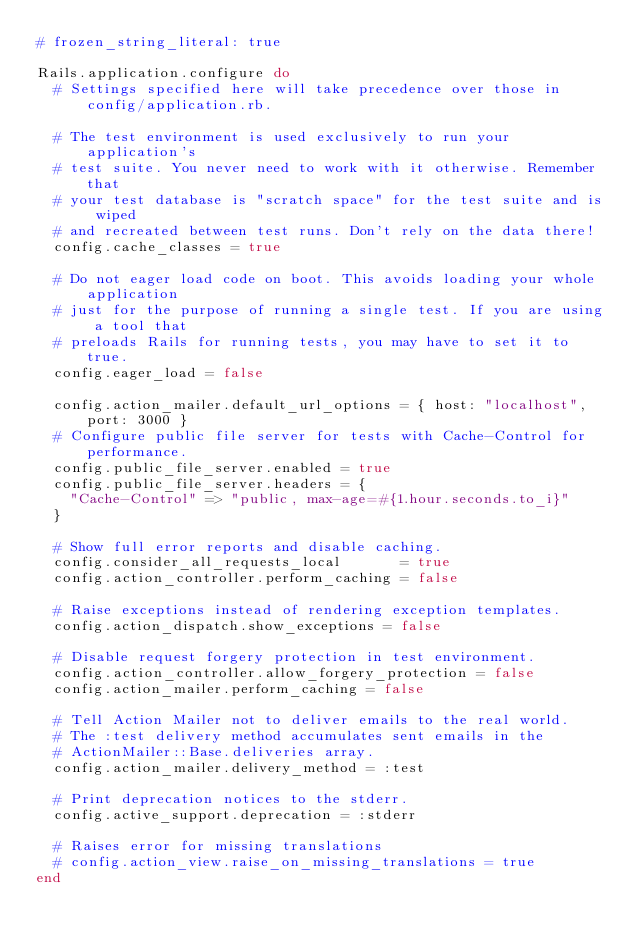<code> <loc_0><loc_0><loc_500><loc_500><_Ruby_># frozen_string_literal: true

Rails.application.configure do
  # Settings specified here will take precedence over those in config/application.rb.

  # The test environment is used exclusively to run your application's
  # test suite. You never need to work with it otherwise. Remember that
  # your test database is "scratch space" for the test suite and is wiped
  # and recreated between test runs. Don't rely on the data there!
  config.cache_classes = true

  # Do not eager load code on boot. This avoids loading your whole application
  # just for the purpose of running a single test. If you are using a tool that
  # preloads Rails for running tests, you may have to set it to true.
  config.eager_load = false

  config.action_mailer.default_url_options = { host: "localhost", port: 3000 }
  # Configure public file server for tests with Cache-Control for performance.
  config.public_file_server.enabled = true
  config.public_file_server.headers = {
    "Cache-Control" => "public, max-age=#{1.hour.seconds.to_i}"
  }

  # Show full error reports and disable caching.
  config.consider_all_requests_local       = true
  config.action_controller.perform_caching = false

  # Raise exceptions instead of rendering exception templates.
  config.action_dispatch.show_exceptions = false

  # Disable request forgery protection in test environment.
  config.action_controller.allow_forgery_protection = false
  config.action_mailer.perform_caching = false

  # Tell Action Mailer not to deliver emails to the real world.
  # The :test delivery method accumulates sent emails in the
  # ActionMailer::Base.deliveries array.
  config.action_mailer.delivery_method = :test

  # Print deprecation notices to the stderr.
  config.active_support.deprecation = :stderr

  # Raises error for missing translations
  # config.action_view.raise_on_missing_translations = true
end
</code> 